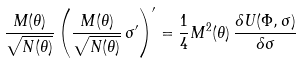<formula> <loc_0><loc_0><loc_500><loc_500>\frac { M ( \theta ) } { \sqrt { N ( \theta ) } } \left ( \frac { M ( \theta ) } { \sqrt { N ( \theta ) } } \, \sigma ^ { \prime } \right ) ^ { \prime } = \frac { 1 } { 4 } M ^ { 2 } ( \theta ) \, \frac { \delta U ( \Phi , \sigma ) } { \delta \sigma }</formula> 